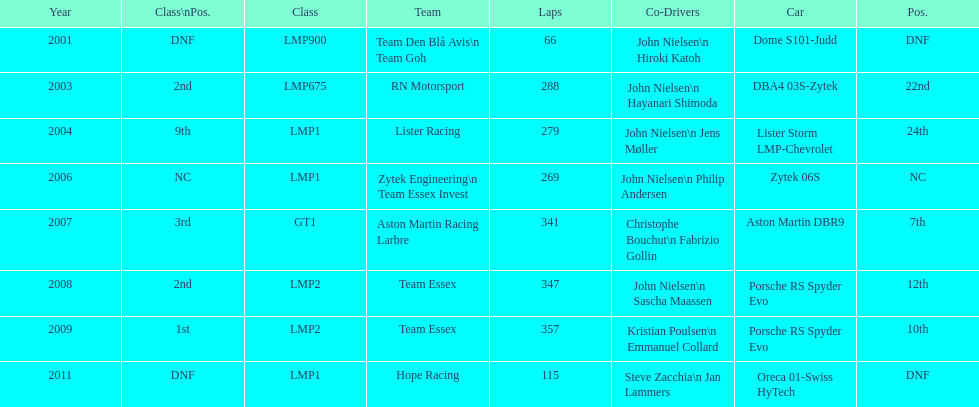Who was john nielsen co-driver for team lister in 2004? Jens Møller. 